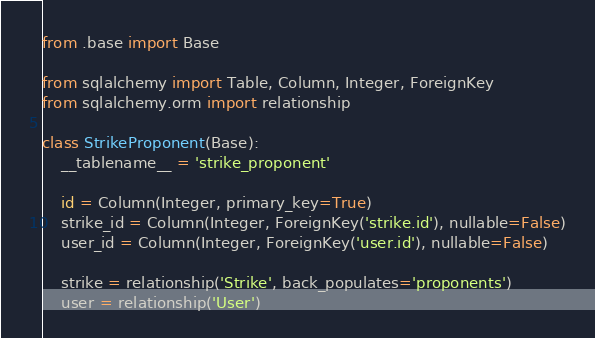<code> <loc_0><loc_0><loc_500><loc_500><_Python_>from .base import Base

from sqlalchemy import Table, Column, Integer, ForeignKey
from sqlalchemy.orm import relationship

class StrikeProponent(Base):
    __tablename__ = 'strike_proponent'
    
    id = Column(Integer, primary_key=True)
    strike_id = Column(Integer, ForeignKey('strike.id'), nullable=False)
    user_id = Column(Integer, ForeignKey('user.id'), nullable=False)
    
    strike = relationship('Strike', back_populates='proponents')
    user = relationship('User')</code> 